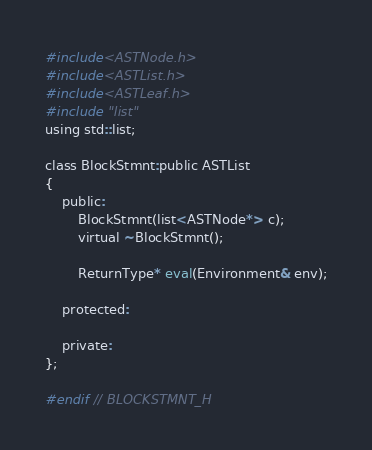<code> <loc_0><loc_0><loc_500><loc_500><_C_>
#include<ASTNode.h>
#include<ASTList.h>
#include<ASTLeaf.h>
#include "list"
using std::list;

class BlockStmnt:public ASTList
{
    public:
        BlockStmnt(list<ASTNode*> c);
        virtual ~BlockStmnt();

        ReturnType* eval(Environment& env);

    protected:

    private:
};

#endif // BLOCKSTMNT_H
</code> 